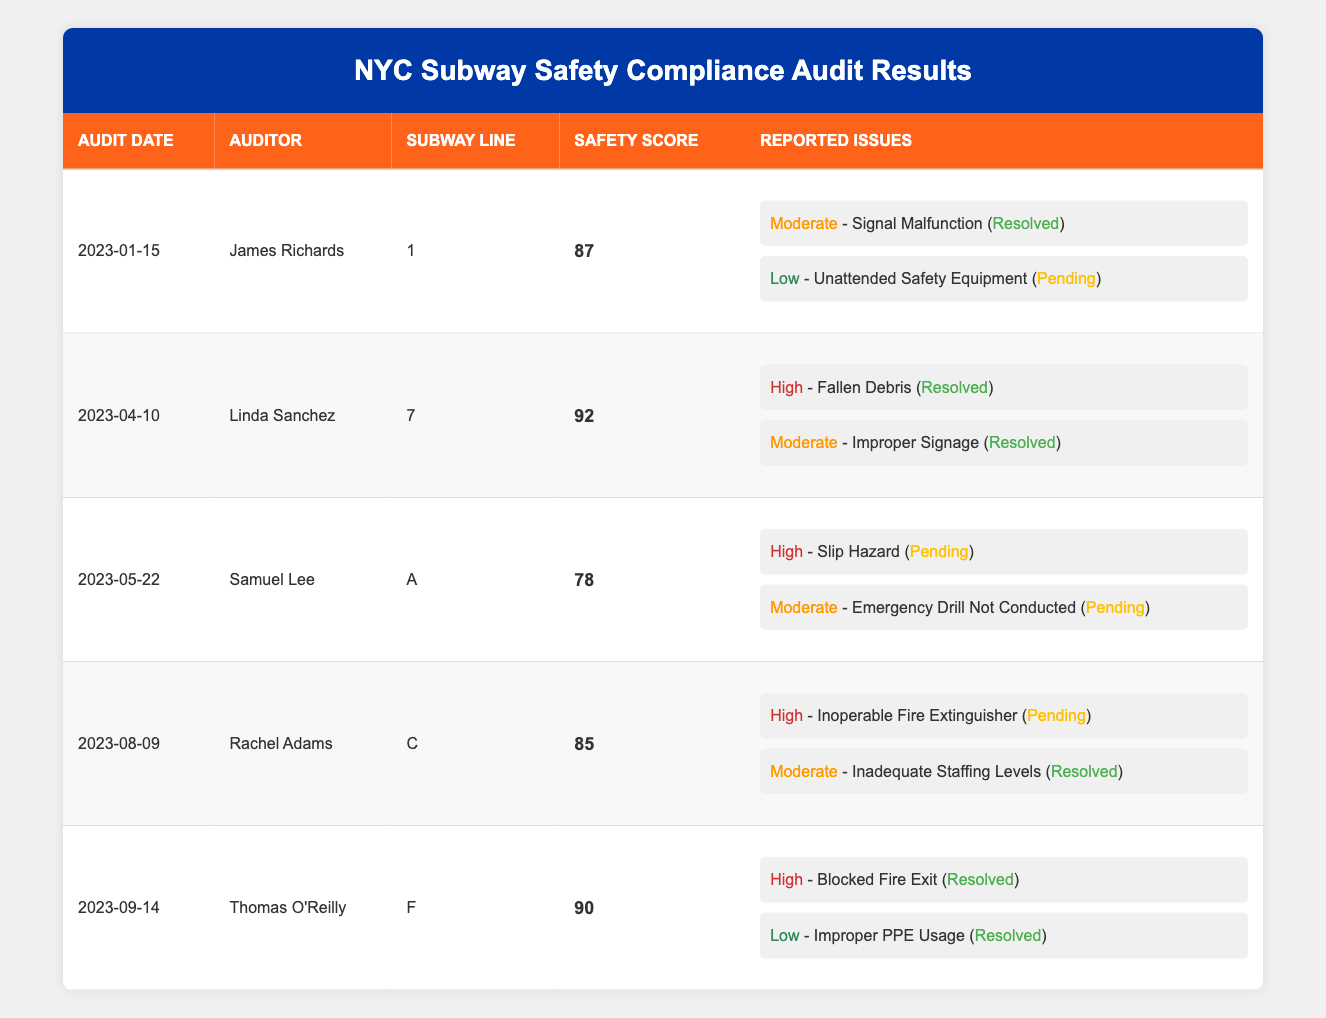What is the safety compliance score for subway line 1? The safety compliance score for subway line 1 is listed directly in the table as 87.
Answer: 87 Who conducted the audit for subway line 7? The audit for subway line 7 was conducted by Linda Sanchez, as indicated in the table.
Answer: Linda Sanchez How many reported issues were resolved during the audit of subway line F? The table shows two reported issues for subway line F, both of which were resolved, making it a total of 2 resolved issues.
Answer: 2 What is the average safety compliance score of all the audited subway lines? The scores are 87, 92, 78, 85, and 90. Adding them gives 432, then dividing by 5 (the number of scores) gives an average of 86.4.
Answer: 86.4 Is there a pending issue related to safety equipment on subway line 1? The table indicates that there is one pending issue related to unattended safety equipment for subway line 1. So, the statement is true.
Answer: Yes Which subway line had the highest safety compliance score? When comparing the scores, subway line 7 has the highest score at 92.
Answer: Subway line 7 How many audits reported high severity issues but also had a safety compliance score above 85? The audit results for subway lines 7 and F reported high severity issues and had scores of 92 and 90 respectively. Therefore, there are 2 such audits.
Answer: 2 Is it true that all reported issues from subway line A are pending? The table shows that subway line A had two reported issues, both pending, but since they could still be under review, it appears this statement is true.
Answer: Yes What is the difference between the highest and lowest safety compliance scores? The highest score is 92 (subway line 7) and the lowest is 78 (subway line A). The difference is 92 - 78 = 14.
Answer: 14 Which audit date had the most issues pending resolution? Subway line A has 2 pending issues, more than any other line, which indicates its audit date of 2023-05-22 had the most pending issues.
Answer: 2023-05-22 